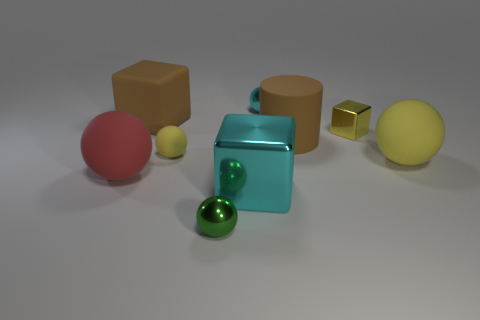What material is the object that is the same color as the matte cylinder?
Provide a short and direct response. Rubber. Are there any large rubber things that have the same color as the small shiny block?
Provide a succinct answer. Yes. The shiny ball that is right of the large object that is in front of the red thing is what color?
Your answer should be very brief. Cyan. Are there any brown cylinders that have the same material as the large red sphere?
Give a very brief answer. Yes. There is a tiny sphere in front of the big matte ball to the right of the small green sphere; what is it made of?
Your answer should be compact. Metal. What number of red matte objects have the same shape as the tiny yellow matte thing?
Your answer should be compact. 1. What is the shape of the red matte thing?
Provide a short and direct response. Sphere. Is the number of matte cubes less than the number of tiny balls?
Keep it short and to the point. Yes. Is there any other thing that has the same size as the yellow metal block?
Ensure brevity in your answer.  Yes. What is the material of the big red object that is the same shape as the small cyan metallic object?
Offer a very short reply. Rubber. 